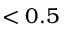Convert formula to latex. <formula><loc_0><loc_0><loc_500><loc_500>< 0 . 5</formula> 